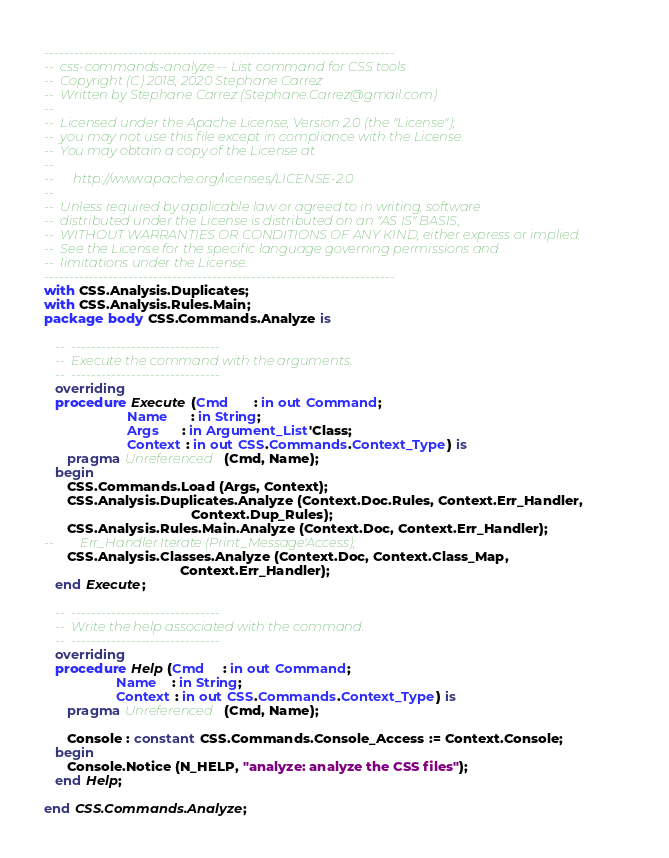Convert code to text. <code><loc_0><loc_0><loc_500><loc_500><_Ada_>-----------------------------------------------------------------------
--  css-commands-analyze -- List command for CSS tools
--  Copyright (C) 2018, 2020 Stephane Carrez
--  Written by Stephane Carrez (Stephane.Carrez@gmail.com)
--
--  Licensed under the Apache License, Version 2.0 (the "License");
--  you may not use this file except in compliance with the License.
--  You may obtain a copy of the License at
--
--      http://www.apache.org/licenses/LICENSE-2.0
--
--  Unless required by applicable law or agreed to in writing, software
--  distributed under the License is distributed on an "AS IS" BASIS,
--  WITHOUT WARRANTIES OR CONDITIONS OF ANY KIND, either express or implied.
--  See the License for the specific language governing permissions and
--  limitations under the License.
-----------------------------------------------------------------------
with CSS.Analysis.Duplicates;
with CSS.Analysis.Rules.Main;
package body CSS.Commands.Analyze is

   --  ------------------------------
   --  Execute the command with the arguments.
   --  ------------------------------
   overriding
   procedure Execute (Cmd       : in out Command;
                      Name      : in String;
                      Args      : in Argument_List'Class;
                      Context : in out CSS.Commands.Context_Type) is
      pragma Unreferenced (Cmd, Name);
   begin
      CSS.Commands.Load (Args, Context);
      CSS.Analysis.Duplicates.Analyze (Context.Doc.Rules, Context.Err_Handler,
                                       Context.Dup_Rules);
      CSS.Analysis.Rules.Main.Analyze (Context.Doc, Context.Err_Handler);
--        Err_Handler.Iterate (Print_Message'Access);
      CSS.Analysis.Classes.Analyze (Context.Doc, Context.Class_Map,
                                    Context.Err_Handler);
   end Execute;

   --  ------------------------------
   --  Write the help associated with the command.
   --  ------------------------------
   overriding
   procedure Help (Cmd     : in out Command;
                   Name    : in String;
                   Context : in out CSS.Commands.Context_Type) is
      pragma Unreferenced (Cmd, Name);

      Console : constant CSS.Commands.Console_Access := Context.Console;
   begin
      Console.Notice (N_HELP, "analyze: analyze the CSS files");
   end Help;

end CSS.Commands.Analyze;
</code> 